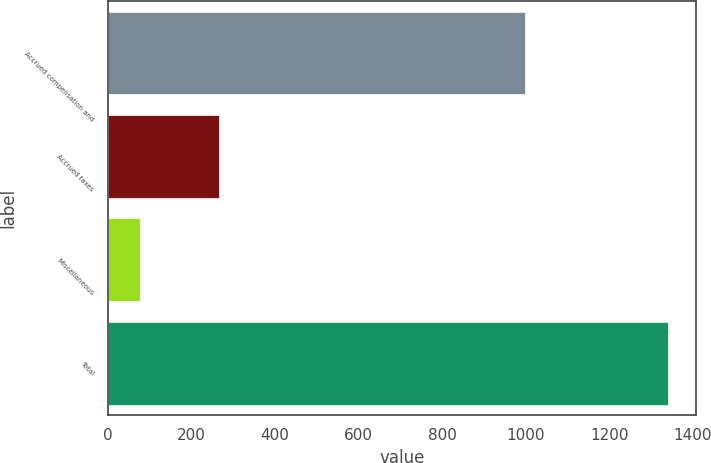Convert chart to OTSL. <chart><loc_0><loc_0><loc_500><loc_500><bar_chart><fcel>Accrued compensation and<fcel>Accrued taxes<fcel>Miscellaneous<fcel>Total<nl><fcel>999.4<fcel>265.3<fcel>76.3<fcel>1341<nl></chart> 